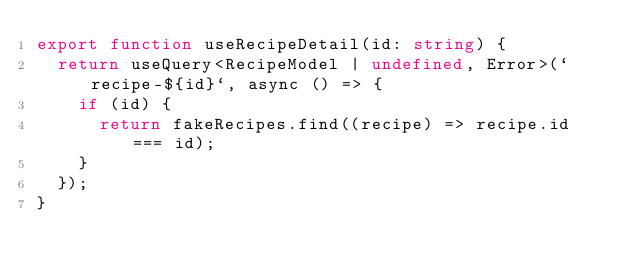<code> <loc_0><loc_0><loc_500><loc_500><_TypeScript_>export function useRecipeDetail(id: string) {
  return useQuery<RecipeModel | undefined, Error>(`recipe-${id}`, async () => {
    if (id) {
      return fakeRecipes.find((recipe) => recipe.id === id);
    }
  });
}
</code> 